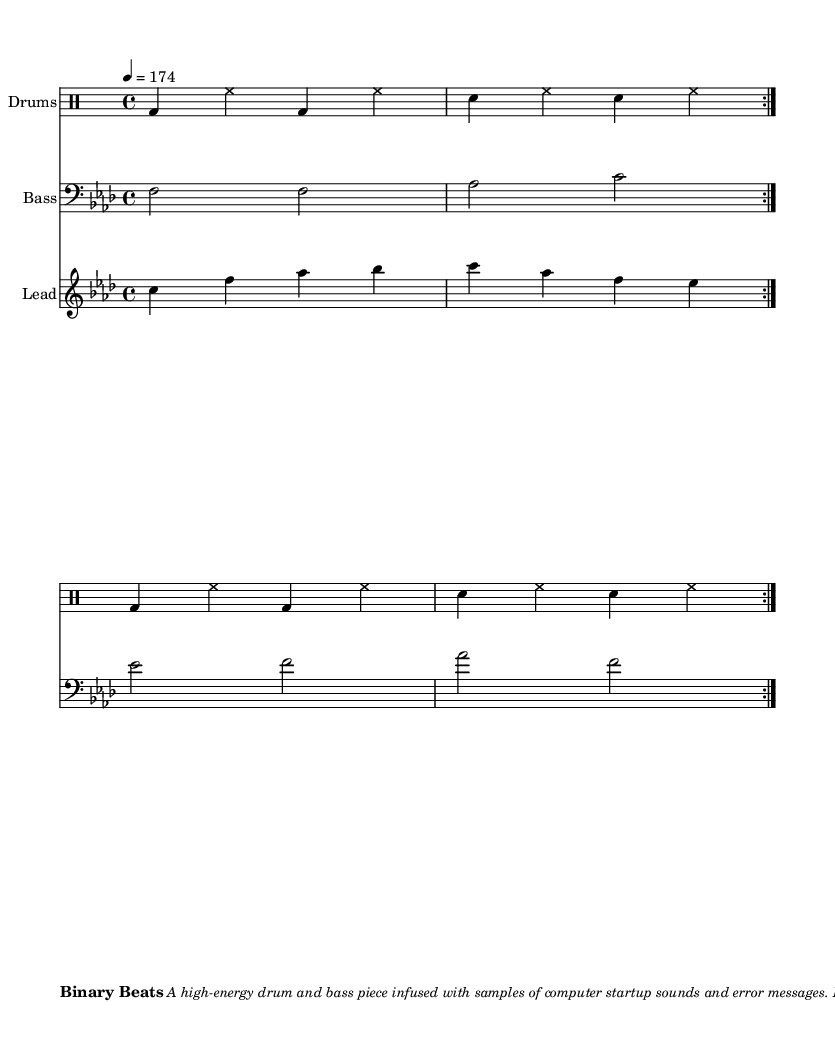What is the key signature of this music? The key signature is indicated at the beginning of the score with flats. There are four flats (B♭, E♭, A♭, D♭), which corresponds to F minor.
Answer: F minor What is the time signature of the piece? The time signature is found at the beginning of the score. It shows a fraction where the numerator is 4 and the denominator is 4, indicating a 4/4 time signature.
Answer: 4/4 What is the tempo marking of this piece? The tempo marking is specified with a number at the beginning of the music. It indicates 4 equals 174, meaning that there are 174 BPM in the quarter note.
Answer: 174 How many measures are repeated in the drums part? The repeat symbol at the beginning of the drums part shows that the section is meant to be played twice. Since it is clearly marked with the repeat notation, we can see that it repeats for a total of two iterations.
Answer: 2 What instruments are used in this composition? The composition lists three instruments, which are indicated in the score. They are labeled as "Drums," "Bass," and "Lead," reflecting the different musical roles they play.
Answer: Drums, Bass, Lead What types of sounds are incorporated into the music? The description in the markup section states that samples of computer startup sounds and error messages are used, specifically mentioning Windows XP Startup, Error Beep, and Dial-up Modem samples.
Answer: Computer startup sounds, error messages How does the lead part relate to the bass part? To analyze the relation, we observe that both parts are repeated twice in the score. The frequency of the notes played in the lead part complements the bass line, creating a high-energy contrast that is typical in drum and bass music. The lead uses different pitches that harmonically support the bass notes.
Answer: They complement each other 